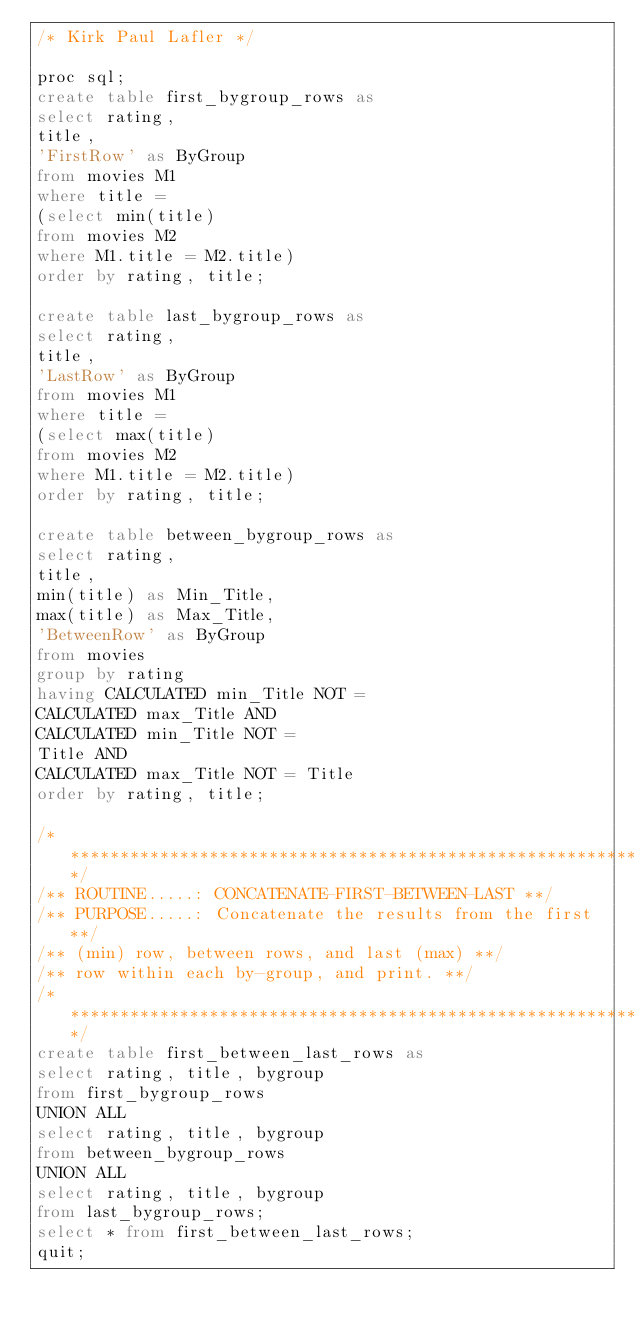Convert code to text. <code><loc_0><loc_0><loc_500><loc_500><_SQL_>/* Kirk Paul Lafler */

proc sql;
create table first_bygroup_rows as
select rating,
title,
'FirstRow' as ByGroup
from movies M1
where title =
(select min(title)
from movies M2
where M1.title = M2.title)
order by rating, title;

create table last_bygroup_rows as
select rating,
title,
'LastRow' as ByGroup
from movies M1
where title =
(select max(title)
from movies M2
where M1.title = M2.title)
order by rating, title;

create table between_bygroup_rows as
select rating,
title,
min(title) as Min_Title,
max(title) as Max_Title,
'BetweenRow' as ByGroup
from movies
group by rating
having CALCULATED min_Title NOT =
CALCULATED max_Title AND
CALCULATED min_Title NOT =
Title AND
CALCULATED max_Title NOT = Title
order by rating, title;

/***********************************************************/
/** ROUTINE.....: CONCATENATE-FIRST-BETWEEN-LAST **/
/** PURPOSE.....: Concatenate the results from the first **/
/** (min) row, between rows, and last (max) **/
/** row within each by-group, and print. **/
/***********************************************************/
create table first_between_last_rows as
select rating, title, bygroup
from first_bygroup_rows
UNION ALL
select rating, title, bygroup
from between_bygroup_rows
UNION ALL
select rating, title, bygroup
from last_bygroup_rows;
select * from first_between_last_rows;
quit;
</code> 